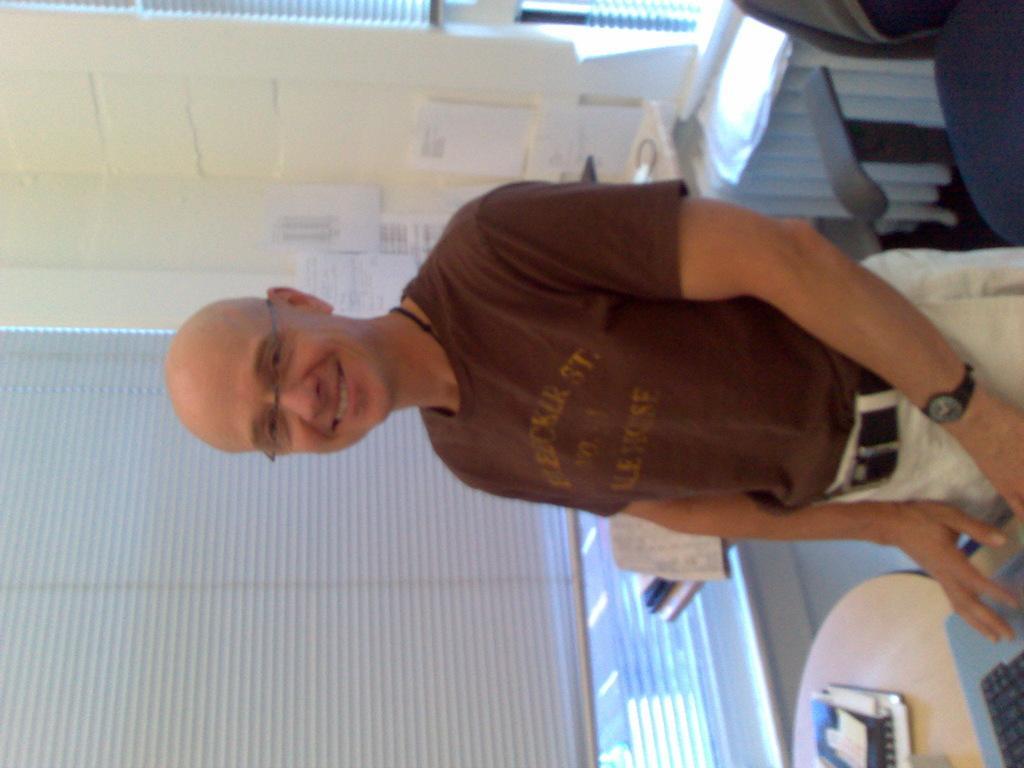Please provide a concise description of this image. In this image there is a person standing and smiling, there is a laptop and book on the table, and in the background there is a chair, window shutter ,papers stick to the wall. 